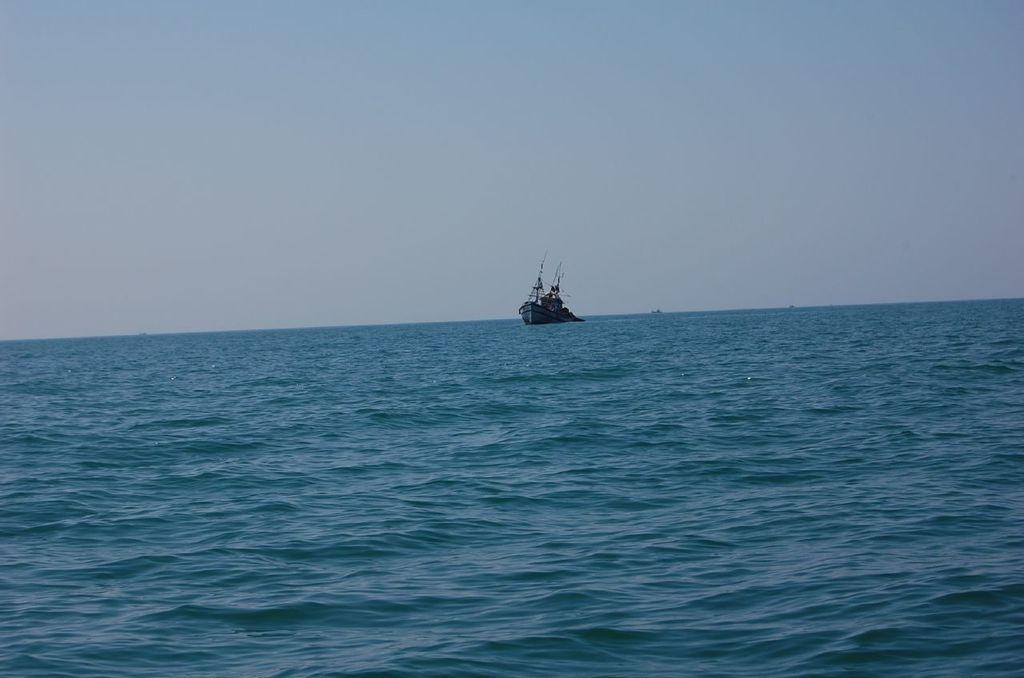Where was the picture taken? The picture was clicked outside the city. What can be seen in the center of the image? There is a boat in the water body in the center of the image. What is visible in the background of the image? There is a sky visible in the background of the image. How many necks are visible in the image? There are no necks visible in the image. Is there a volleyball game happening in the water body in the image? There is no volleyball game happening in the water body in the image. 